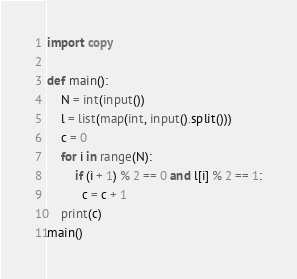<code> <loc_0><loc_0><loc_500><loc_500><_Python_>import copy

def main():
    N = int(input())
    l = list(map(int, input().split()))
    c = 0
    for i in range(N):
        if (i + 1) % 2 == 0 and l[i] % 2 == 1:
          c = c + 1
    print(c)
main()</code> 